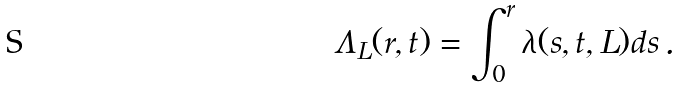<formula> <loc_0><loc_0><loc_500><loc_500>\Lambda _ { L } ( r , t ) = \int _ { 0 } ^ { r } \lambda ( s , t , L ) d s \, .</formula> 